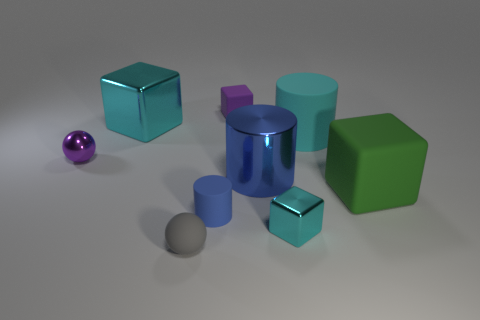What shape is the cyan thing that is made of the same material as the big cyan cube?
Keep it short and to the point. Cube. There is a tiny purple object that is on the left side of the small gray rubber ball; is its shape the same as the large blue thing on the left side of the green matte object?
Provide a succinct answer. No. Are there fewer small purple blocks that are right of the rubber sphere than large cyan cubes that are behind the purple rubber thing?
Offer a terse response. No. The object that is the same color as the tiny matte cylinder is what shape?
Keep it short and to the point. Cylinder. How many blue objects have the same size as the purple block?
Provide a short and direct response. 1. Are the small purple object that is to the left of the small purple rubber object and the big cyan cylinder made of the same material?
Offer a very short reply. No. Is there a cyan rubber cylinder?
Give a very brief answer. Yes. There is a green thing that is made of the same material as the small cylinder; what size is it?
Keep it short and to the point. Large. Are there any large metal blocks that have the same color as the large metallic cylinder?
Your response must be concise. No. There is a tiny matte object that is behind the tiny purple shiny ball; is it the same color as the large metal object on the right side of the rubber ball?
Offer a very short reply. No. 